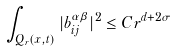Convert formula to latex. <formula><loc_0><loc_0><loc_500><loc_500>\int _ { Q _ { r } ( x , t ) } | b _ { i j } ^ { \alpha \beta } | ^ { 2 } \leq C r ^ { d + 2 \sigma }</formula> 